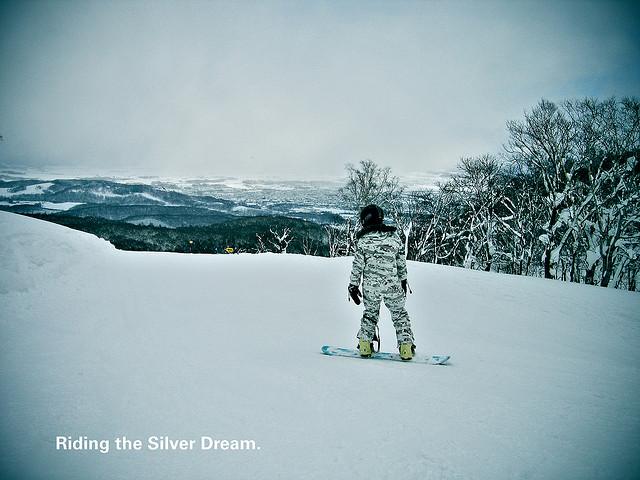Is it warm outside?
Write a very short answer. No. Is this picture taken at sea level?
Short answer required. No. Is he snowboarding?
Concise answer only. Yes. Is this man wearing correct safety gear for this stunt?
Short answer required. Yes. Is it a humid climate here?
Answer briefly. No. 